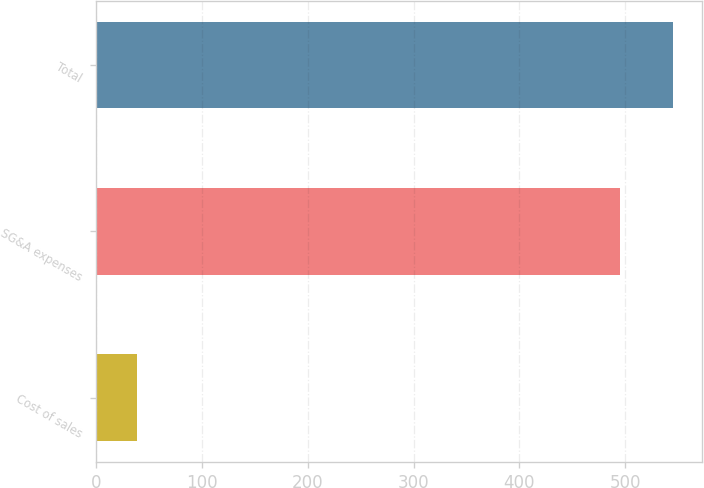<chart> <loc_0><loc_0><loc_500><loc_500><bar_chart><fcel>Cost of sales<fcel>SG&A expenses<fcel>Total<nl><fcel>39<fcel>495<fcel>545.3<nl></chart> 